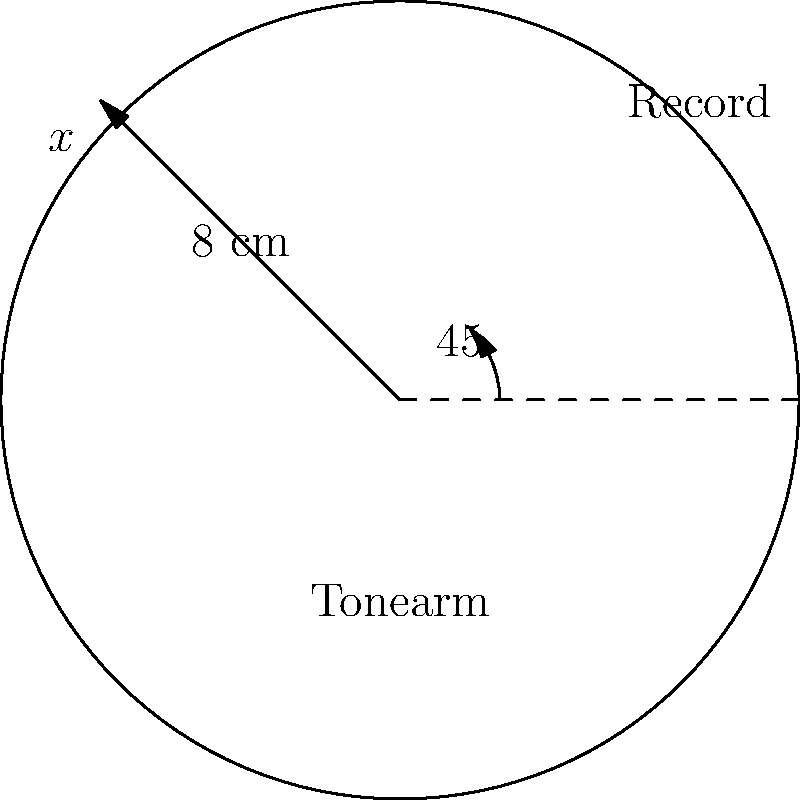A vinyl enthusiast is setting up a turntable and needs to adjust the tonearm. The tonearm is 8 cm long and needs to be positioned so that the stylus touches the outer edge of a 12-inch (30.48 cm) vinyl record. If the distance from the center of the record to the point where the stylus touches is represented by $x$, what angle (in degrees) should the tonearm be rotated from its rest position parallel to the record's diameter? Round your answer to the nearest degree. Let's approach this step-by-step:

1) First, we need to find the value of $x$. The radius of a 12-inch record is 6 inches or 15.24 cm.

2) Now we have a right-angled triangle with:
   - Hypotenuse (tonearm length) = 8 cm
   - Adjacent side (radius) = 15.24 cm

3) We need to find the angle between the hypotenuse and the adjacent side. This is a perfect scenario for the inverse cosine function (arccos or cos⁻¹).

4) The cosine of an angle in a right triangle is given by:
   $$\cos \theta = \frac{\text{adjacent}}{\text{hypotenuse}}$$

5) Therefore, our angle θ is given by:
   $$\theta = \arccos\left(\frac{\text{adjacent}}{\text{hypotenuse}}\right)$$

6) Plugging in our values:
   $$\theta = \arccos\left(\frac{15.24}{8}\right)$$

7) Using a calculator:
   $$\theta \approx 0.7791 \text{ radians}$$

8) Converting to degrees:
   $$\theta \approx 0.7791 \times \frac{180}{\pi} \approx 44.65°$$

9) Rounding to the nearest degree:
   $$\theta \approx 45°$$

Therefore, the tonearm should be rotated approximately 45° from its rest position.
Answer: 45° 